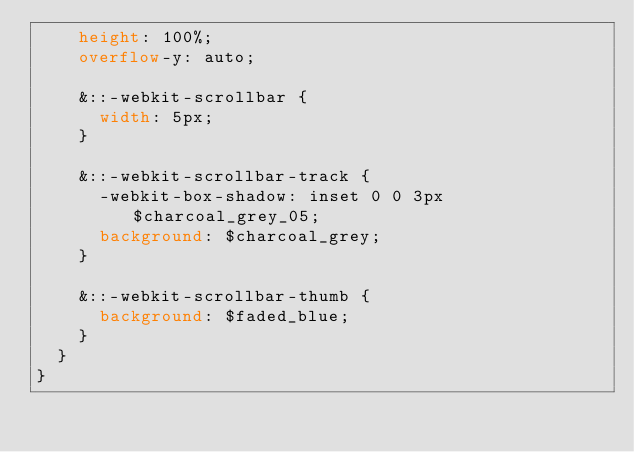Convert code to text. <code><loc_0><loc_0><loc_500><loc_500><_CSS_>    height: 100%;
    overflow-y: auto;

    &::-webkit-scrollbar {
      width: 5px;
    }

    &::-webkit-scrollbar-track {
      -webkit-box-shadow: inset 0 0 3px $charcoal_grey_05;
      background: $charcoal_grey;
    }

    &::-webkit-scrollbar-thumb {
      background: $faded_blue;
    }
  }
}
</code> 